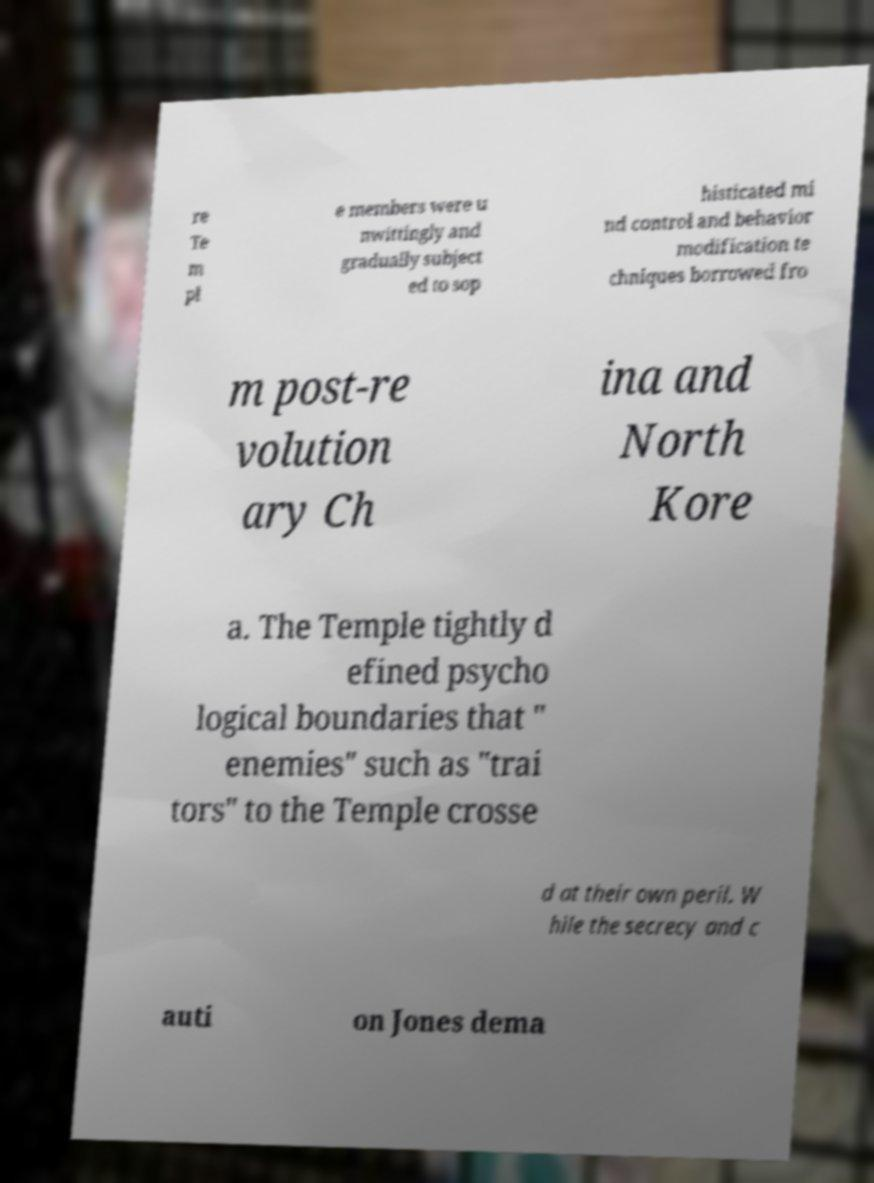I need the written content from this picture converted into text. Can you do that? re Te m pl e members were u nwittingly and gradually subject ed to sop histicated mi nd control and behavior modification te chniques borrowed fro m post-re volution ary Ch ina and North Kore a. The Temple tightly d efined psycho logical boundaries that " enemies" such as "trai tors" to the Temple crosse d at their own peril. W hile the secrecy and c auti on Jones dema 